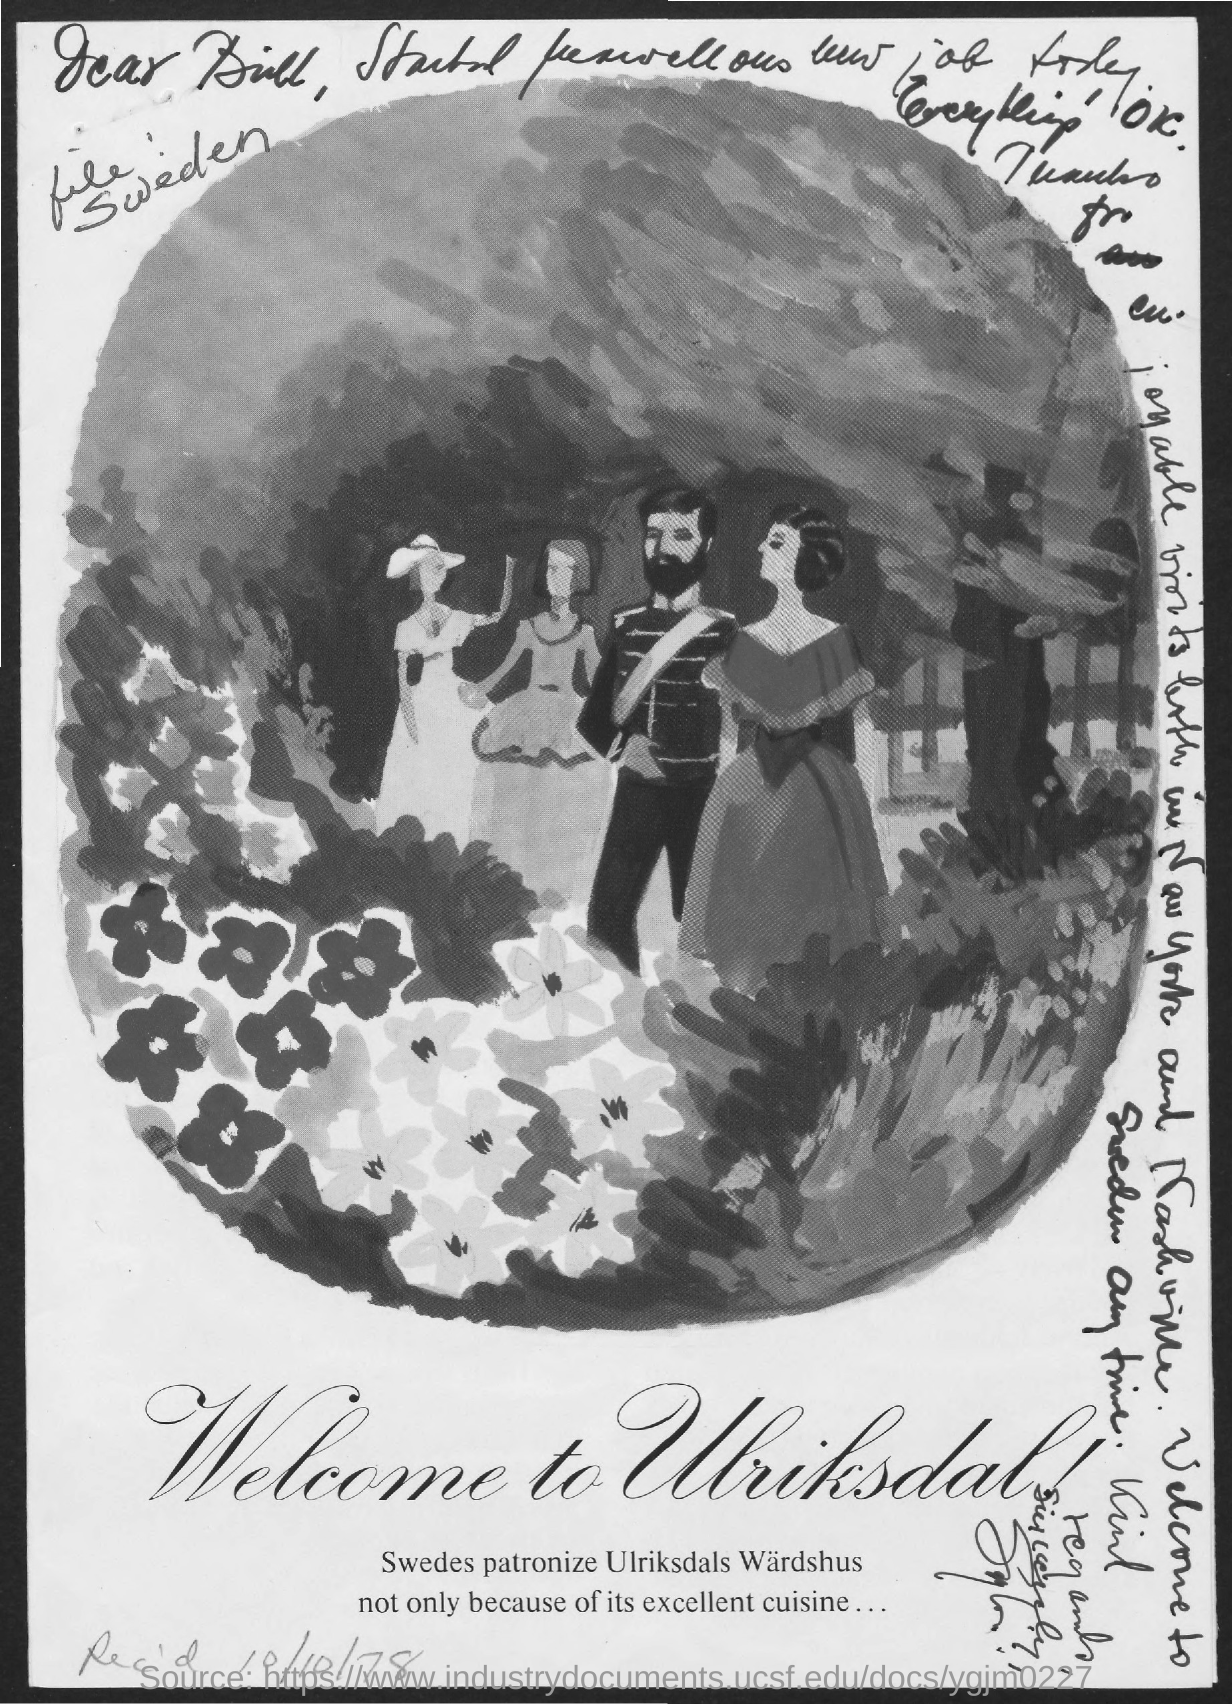What is written below the image?
Ensure brevity in your answer.  Welcome to Ulriksdal. 